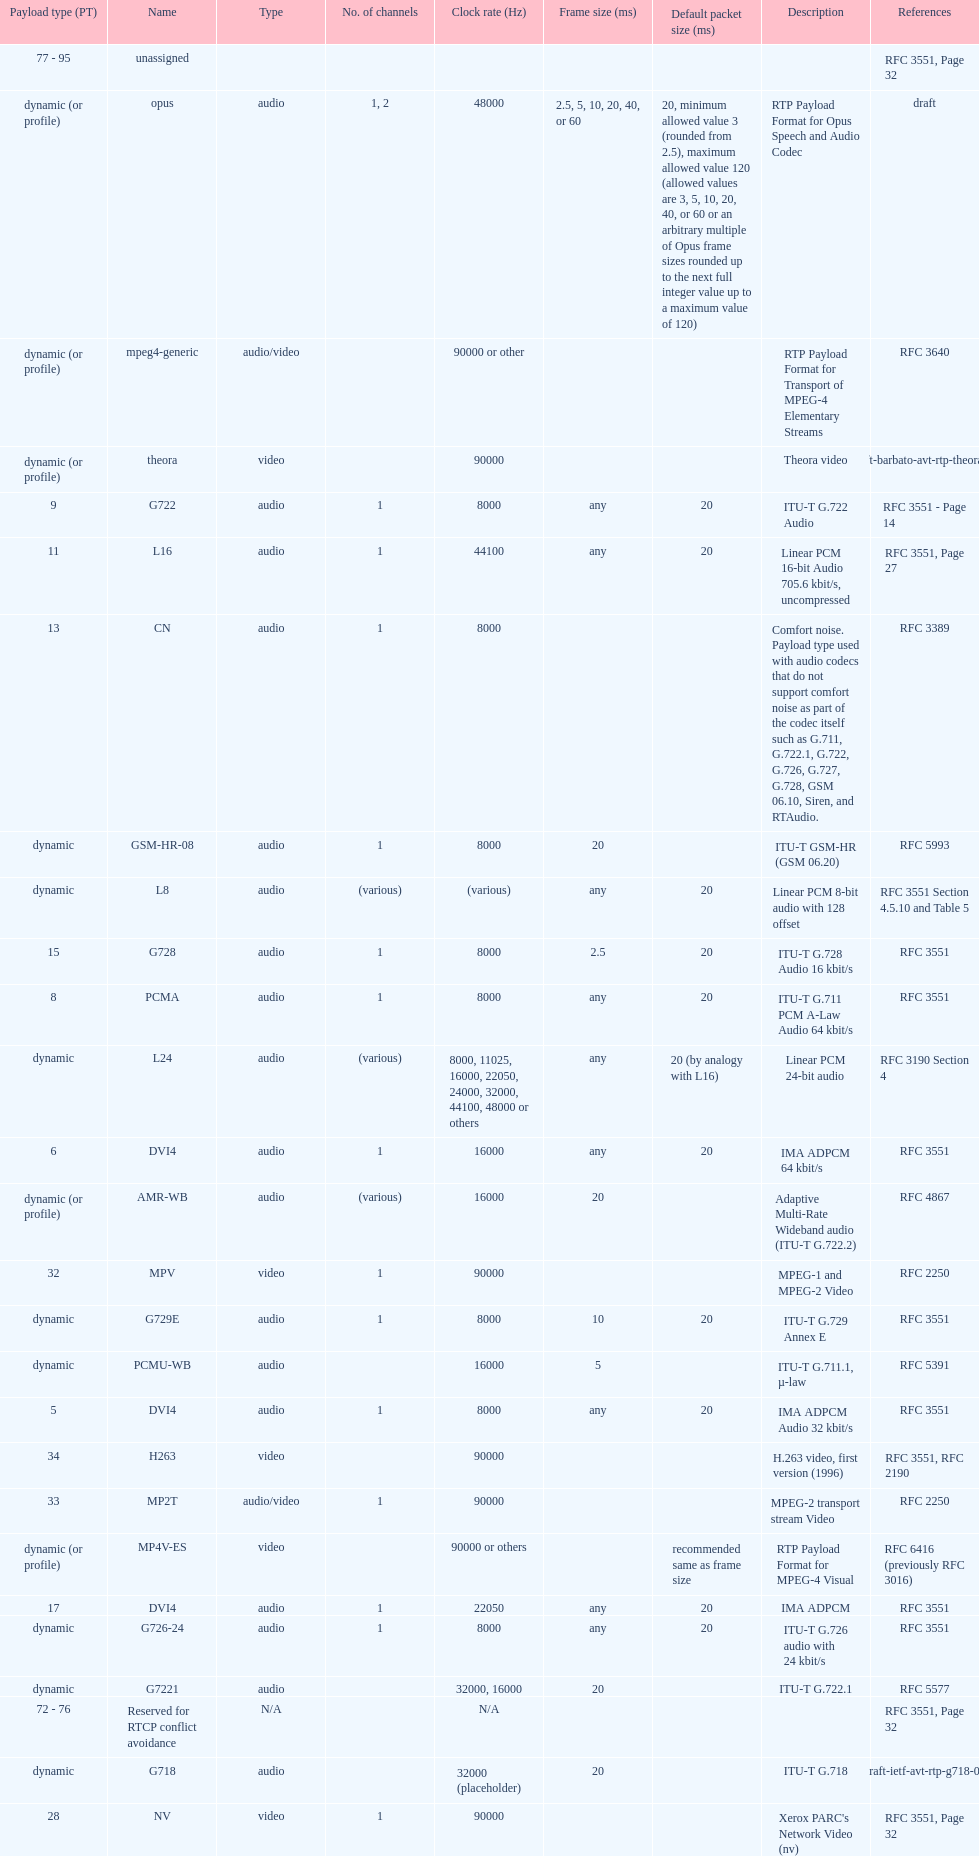The rtp/avp audio and video payload types include an audio type called qcelp and its frame size is how many ms? 20. 